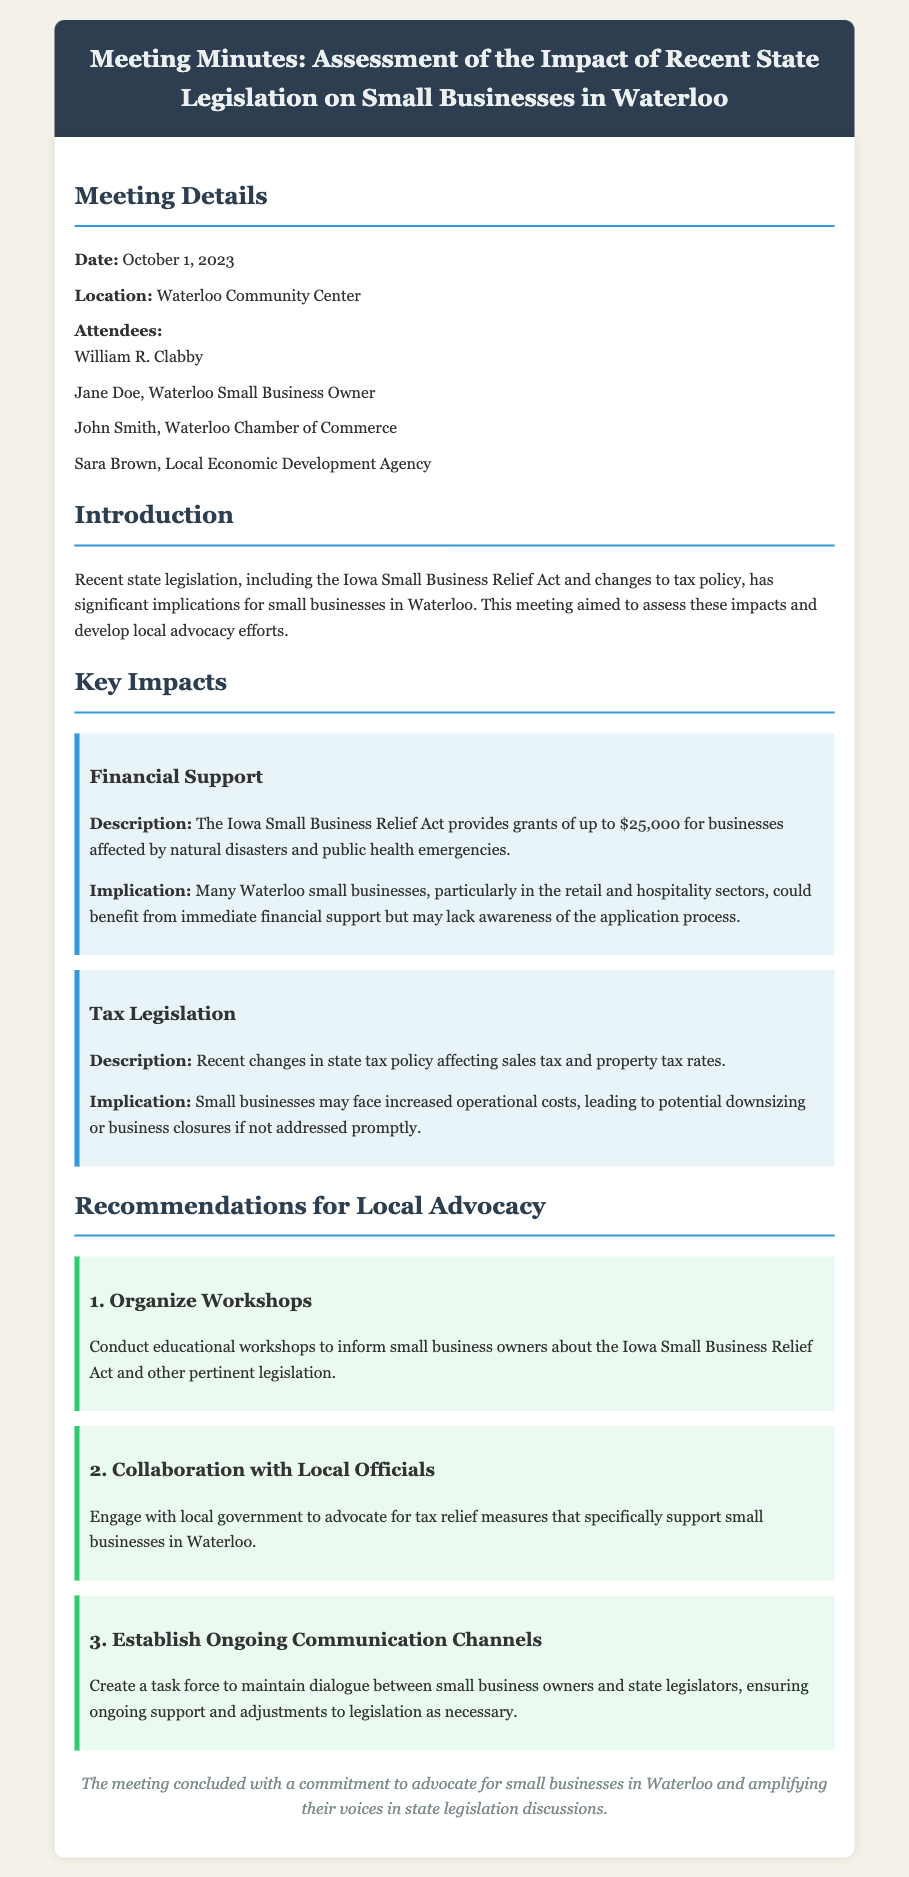What is the date of the meeting? The date of the meeting is listed in the document under Meeting Details.
Answer: October 1, 2023 Who is one of the attendees of the meeting? The document lists attendees, including William R. Clabby.
Answer: William R. Clabby What act was discussed regarding financial support for small businesses? The legislation mentioned in relation to financial support is named in the document.
Answer: Iowa Small Business Relief Act What is one implication of recent tax legislation for small businesses? The document explains implications associated with the changes in tax policy affecting small businesses.
Answer: Increased operational costs How many recommendations are proposed for local advocacy? The number of recommendations can be found in the Recommendations for Local Advocacy section of the document.
Answer: Three What is one suggested action to support small businesses? The document provides specific recommendations for actions to be taken, one of which is mentioned.
Answer: Organize Workshops What is the purpose of the meeting? The document states the primary aim of the meeting in the Introduction section.
Answer: Assess the impacts of recent state legislation What type of document is this? The structure and content reveal the formalities typical of minutes of a meeting.
Answer: Meeting minutes 